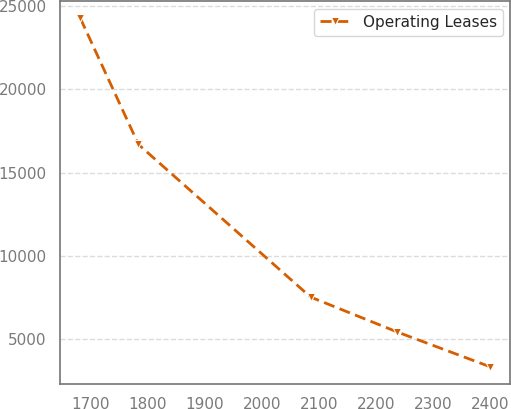Convert chart. <chart><loc_0><loc_0><loc_500><loc_500><line_chart><ecel><fcel>Operating Leases<nl><fcel>1681.76<fcel>24261.9<nl><fcel>1783.62<fcel>16690.7<nl><fcel>2085.57<fcel>7527.27<nl><fcel>2237.17<fcel>5435.44<nl><fcel>2400.32<fcel>3343.61<nl></chart> 